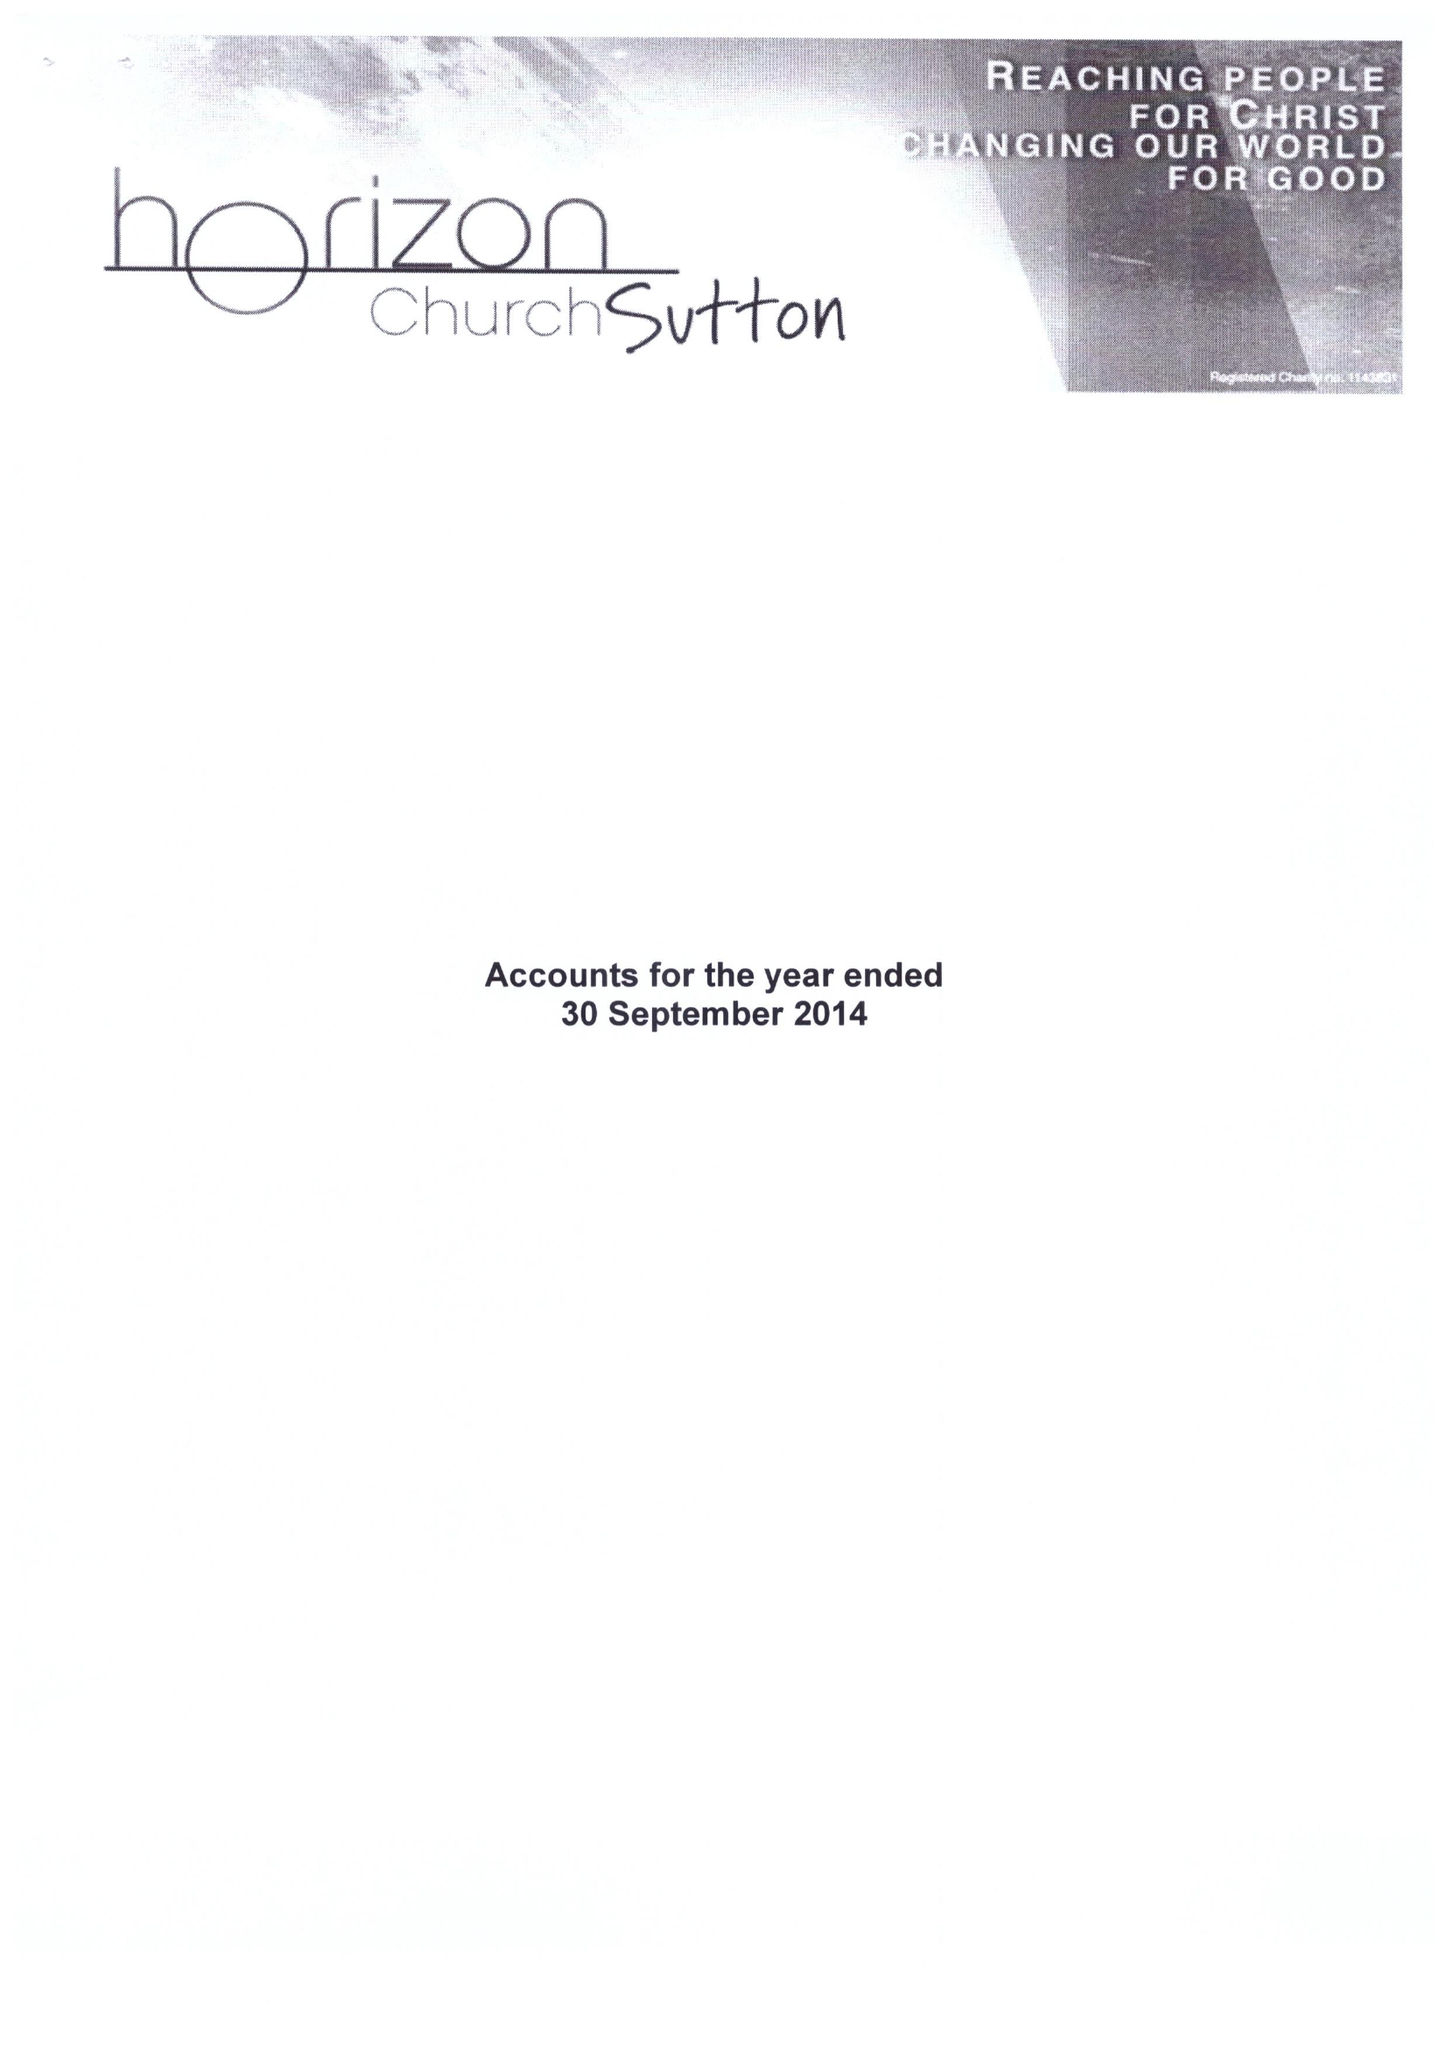What is the value for the charity_name?
Answer the question using a single word or phrase. Horizon Church Sutton 